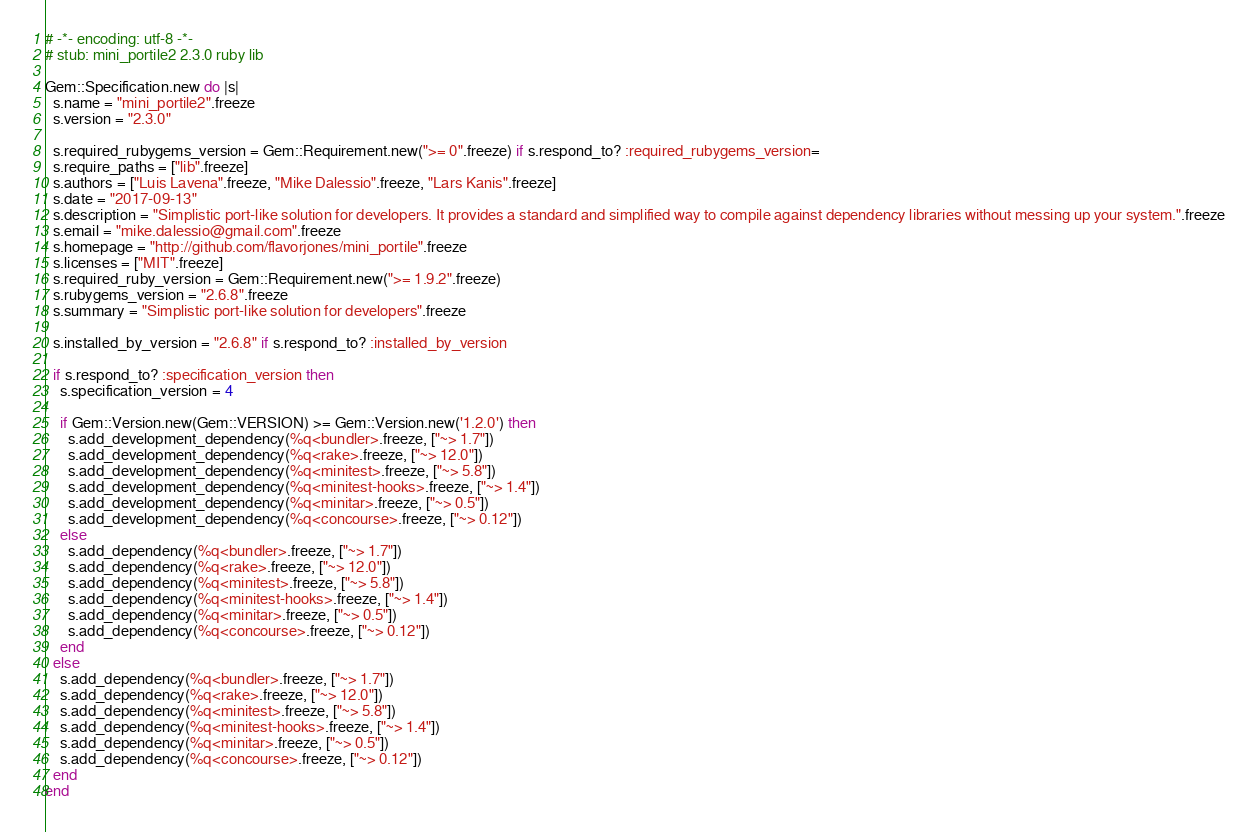Convert code to text. <code><loc_0><loc_0><loc_500><loc_500><_Ruby_># -*- encoding: utf-8 -*-
# stub: mini_portile2 2.3.0 ruby lib

Gem::Specification.new do |s|
  s.name = "mini_portile2".freeze
  s.version = "2.3.0"

  s.required_rubygems_version = Gem::Requirement.new(">= 0".freeze) if s.respond_to? :required_rubygems_version=
  s.require_paths = ["lib".freeze]
  s.authors = ["Luis Lavena".freeze, "Mike Dalessio".freeze, "Lars Kanis".freeze]
  s.date = "2017-09-13"
  s.description = "Simplistic port-like solution for developers. It provides a standard and simplified way to compile against dependency libraries without messing up your system.".freeze
  s.email = "mike.dalessio@gmail.com".freeze
  s.homepage = "http://github.com/flavorjones/mini_portile".freeze
  s.licenses = ["MIT".freeze]
  s.required_ruby_version = Gem::Requirement.new(">= 1.9.2".freeze)
  s.rubygems_version = "2.6.8".freeze
  s.summary = "Simplistic port-like solution for developers".freeze

  s.installed_by_version = "2.6.8" if s.respond_to? :installed_by_version

  if s.respond_to? :specification_version then
    s.specification_version = 4

    if Gem::Version.new(Gem::VERSION) >= Gem::Version.new('1.2.0') then
      s.add_development_dependency(%q<bundler>.freeze, ["~> 1.7"])
      s.add_development_dependency(%q<rake>.freeze, ["~> 12.0"])
      s.add_development_dependency(%q<minitest>.freeze, ["~> 5.8"])
      s.add_development_dependency(%q<minitest-hooks>.freeze, ["~> 1.4"])
      s.add_development_dependency(%q<minitar>.freeze, ["~> 0.5"])
      s.add_development_dependency(%q<concourse>.freeze, ["~> 0.12"])
    else
      s.add_dependency(%q<bundler>.freeze, ["~> 1.7"])
      s.add_dependency(%q<rake>.freeze, ["~> 12.0"])
      s.add_dependency(%q<minitest>.freeze, ["~> 5.8"])
      s.add_dependency(%q<minitest-hooks>.freeze, ["~> 1.4"])
      s.add_dependency(%q<minitar>.freeze, ["~> 0.5"])
      s.add_dependency(%q<concourse>.freeze, ["~> 0.12"])
    end
  else
    s.add_dependency(%q<bundler>.freeze, ["~> 1.7"])
    s.add_dependency(%q<rake>.freeze, ["~> 12.0"])
    s.add_dependency(%q<minitest>.freeze, ["~> 5.8"])
    s.add_dependency(%q<minitest-hooks>.freeze, ["~> 1.4"])
    s.add_dependency(%q<minitar>.freeze, ["~> 0.5"])
    s.add_dependency(%q<concourse>.freeze, ["~> 0.12"])
  end
end
</code> 